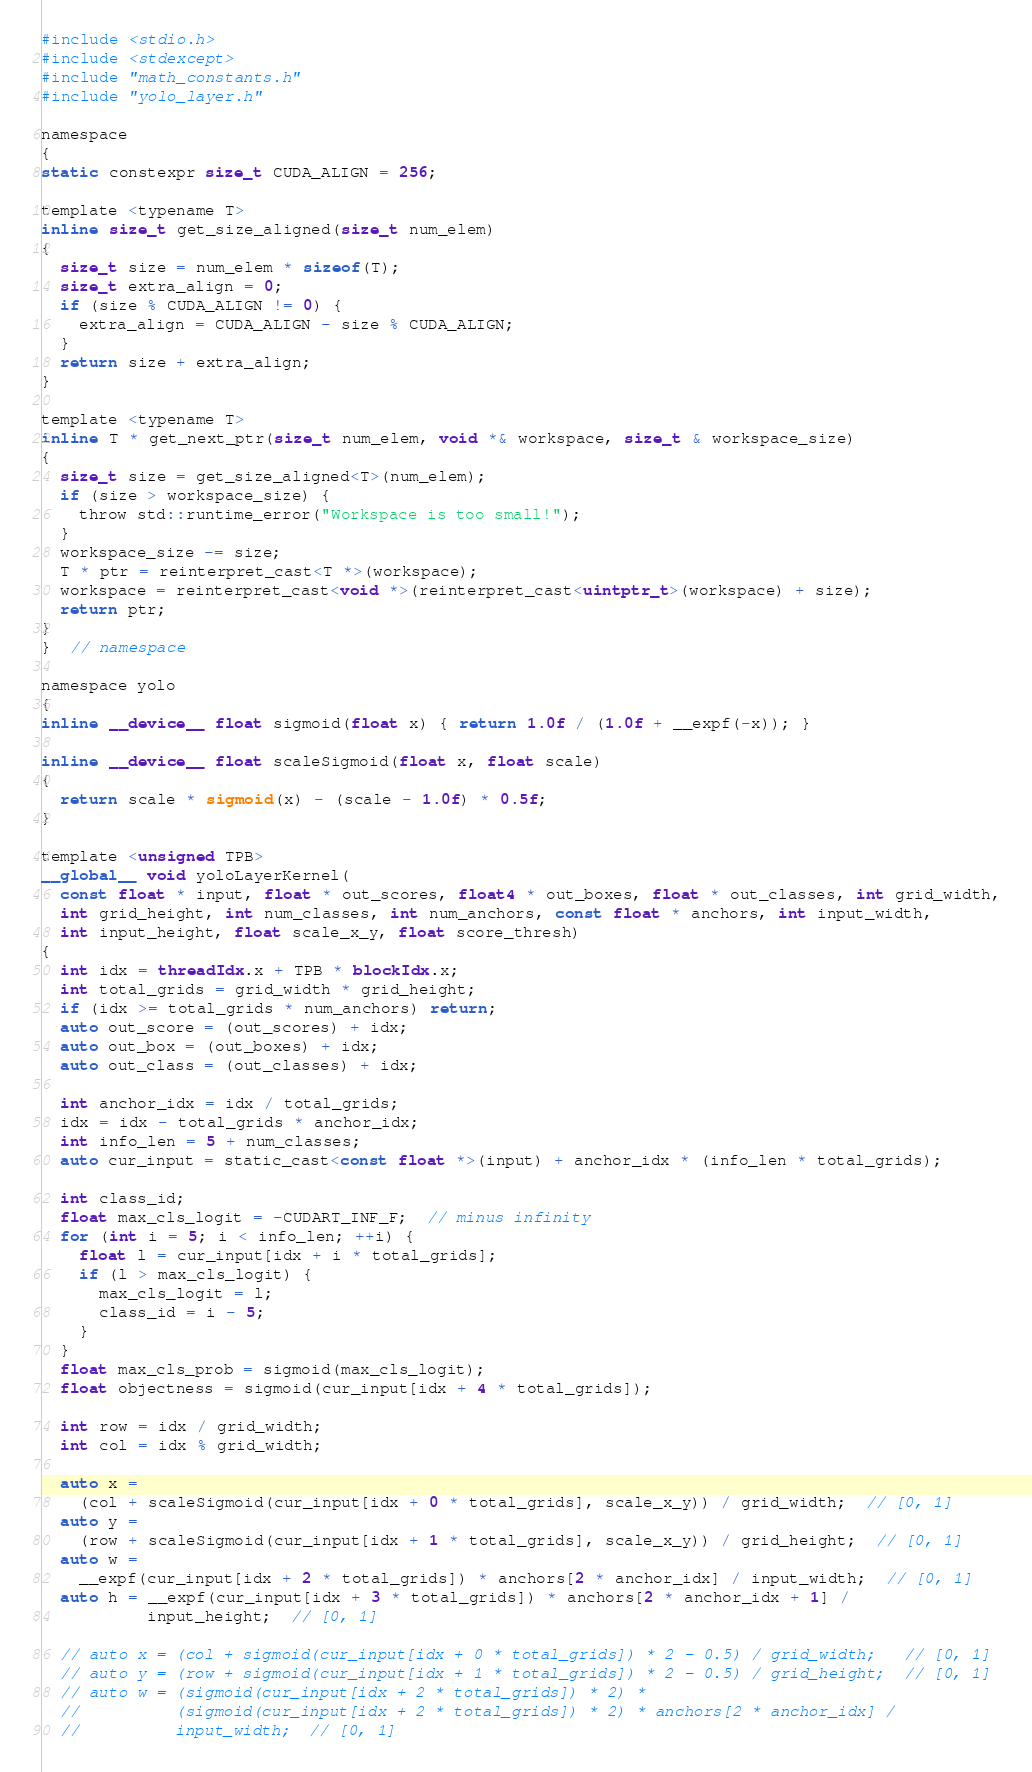<code> <loc_0><loc_0><loc_500><loc_500><_Cuda_>#include <stdio.h>
#include <stdexcept>
#include "math_constants.h"
#include "yolo_layer.h"

namespace
{
static constexpr size_t CUDA_ALIGN = 256;

template <typename T>
inline size_t get_size_aligned(size_t num_elem)
{
  size_t size = num_elem * sizeof(T);
  size_t extra_align = 0;
  if (size % CUDA_ALIGN != 0) {
    extra_align = CUDA_ALIGN - size % CUDA_ALIGN;
  }
  return size + extra_align;
}

template <typename T>
inline T * get_next_ptr(size_t num_elem, void *& workspace, size_t & workspace_size)
{
  size_t size = get_size_aligned<T>(num_elem);
  if (size > workspace_size) {
    throw std::runtime_error("Workspace is too small!");
  }
  workspace_size -= size;
  T * ptr = reinterpret_cast<T *>(workspace);
  workspace = reinterpret_cast<void *>(reinterpret_cast<uintptr_t>(workspace) + size);
  return ptr;
}
}  // namespace

namespace yolo
{
inline __device__ float sigmoid(float x) { return 1.0f / (1.0f + __expf(-x)); }

inline __device__ float scaleSigmoid(float x, float scale)
{
  return scale * sigmoid(x) - (scale - 1.0f) * 0.5f;
}

template <unsigned TPB>
__global__ void yoloLayerKernel(
  const float * input, float * out_scores, float4 * out_boxes, float * out_classes, int grid_width,
  int grid_height, int num_classes, int num_anchors, const float * anchors, int input_width,
  int input_height, float scale_x_y, float score_thresh)
{
  int idx = threadIdx.x + TPB * blockIdx.x;
  int total_grids = grid_width * grid_height;
  if (idx >= total_grids * num_anchors) return;
  auto out_score = (out_scores) + idx;
  auto out_box = (out_boxes) + idx;
  auto out_class = (out_classes) + idx;

  int anchor_idx = idx / total_grids;
  idx = idx - total_grids * anchor_idx;
  int info_len = 5 + num_classes;
  auto cur_input = static_cast<const float *>(input) + anchor_idx * (info_len * total_grids);

  int class_id;
  float max_cls_logit = -CUDART_INF_F;  // minus infinity
  for (int i = 5; i < info_len; ++i) {
    float l = cur_input[idx + i * total_grids];
    if (l > max_cls_logit) {
      max_cls_logit = l;
      class_id = i - 5;
    }
  }
  float max_cls_prob = sigmoid(max_cls_logit);
  float objectness = sigmoid(cur_input[idx + 4 * total_grids]);

  int row = idx / grid_width;
  int col = idx % grid_width;

  auto x =
    (col + scaleSigmoid(cur_input[idx + 0 * total_grids], scale_x_y)) / grid_width;  // [0, 1]
  auto y =
    (row + scaleSigmoid(cur_input[idx + 1 * total_grids], scale_x_y)) / grid_height;  // [0, 1]
  auto w =
    __expf(cur_input[idx + 2 * total_grids]) * anchors[2 * anchor_idx] / input_width;  // [0, 1]
  auto h = __expf(cur_input[idx + 3 * total_grids]) * anchors[2 * anchor_idx + 1] /
           input_height;  // [0, 1]

  // auto x = (col + sigmoid(cur_input[idx + 0 * total_grids]) * 2 - 0.5) / grid_width;   // [0, 1]
  // auto y = (row + sigmoid(cur_input[idx + 1 * total_grids]) * 2 - 0.5) / grid_height;  // [0, 1]
  // auto w = (sigmoid(cur_input[idx + 2 * total_grids]) * 2) *
  //          (sigmoid(cur_input[idx + 2 * total_grids]) * 2) * anchors[2 * anchor_idx] /
  //          input_width;  // [0, 1]</code> 